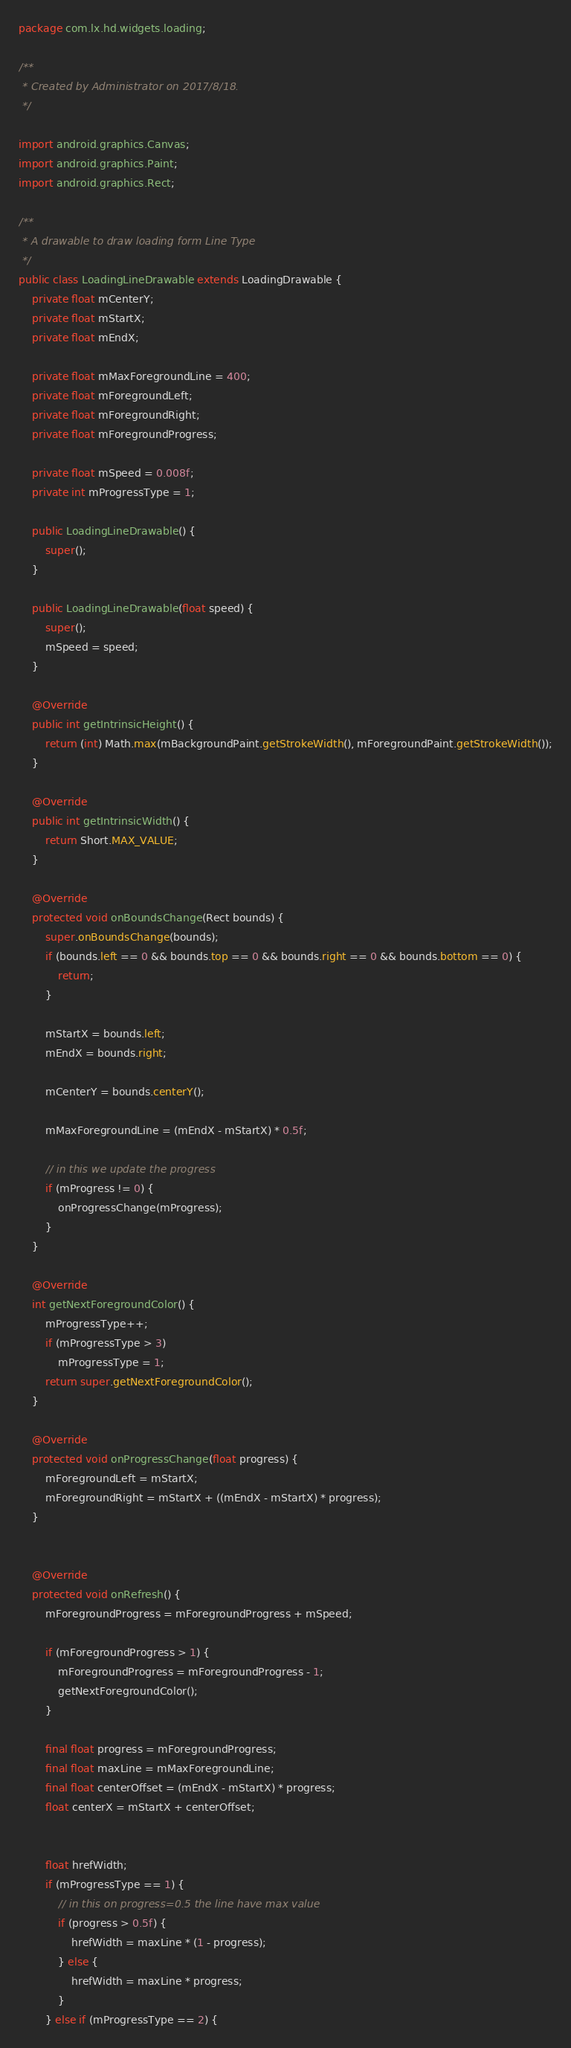<code> <loc_0><loc_0><loc_500><loc_500><_Java_>package com.lx.hd.widgets.loading;

/**
 * Created by Administrator on 2017/8/18.
 */

import android.graphics.Canvas;
import android.graphics.Paint;
import android.graphics.Rect;

/**
 * A drawable to draw loading form Line Type
 */
public class LoadingLineDrawable extends LoadingDrawable {
    private float mCenterY;
    private float mStartX;
    private float mEndX;

    private float mMaxForegroundLine = 400;
    private float mForegroundLeft;
    private float mForegroundRight;
    private float mForegroundProgress;

    private float mSpeed = 0.008f;
    private int mProgressType = 1;

    public LoadingLineDrawable() {
        super();
    }

    public LoadingLineDrawable(float speed) {
        super();
        mSpeed = speed;
    }

    @Override
    public int getIntrinsicHeight() {
        return (int) Math.max(mBackgroundPaint.getStrokeWidth(), mForegroundPaint.getStrokeWidth());
    }

    @Override
    public int getIntrinsicWidth() {
        return Short.MAX_VALUE;
    }

    @Override
    protected void onBoundsChange(Rect bounds) {
        super.onBoundsChange(bounds);
        if (bounds.left == 0 && bounds.top == 0 && bounds.right == 0 && bounds.bottom == 0) {
            return;
        }

        mStartX = bounds.left;
        mEndX = bounds.right;

        mCenterY = bounds.centerY();

        mMaxForegroundLine = (mEndX - mStartX) * 0.5f;

        // in this we update the progress
        if (mProgress != 0) {
            onProgressChange(mProgress);
        }
    }

    @Override
    int getNextForegroundColor() {
        mProgressType++;
        if (mProgressType > 3)
            mProgressType = 1;
        return super.getNextForegroundColor();
    }

    @Override
    protected void onProgressChange(float progress) {
        mForegroundLeft = mStartX;
        mForegroundRight = mStartX + ((mEndX - mStartX) * progress);
    }


    @Override
    protected void onRefresh() {
        mForegroundProgress = mForegroundProgress + mSpeed;

        if (mForegroundProgress > 1) {
            mForegroundProgress = mForegroundProgress - 1;
            getNextForegroundColor();
        }

        final float progress = mForegroundProgress;
        final float maxLine = mMaxForegroundLine;
        final float centerOffset = (mEndX - mStartX) * progress;
        float centerX = mStartX + centerOffset;


        float hrefWidth;
        if (mProgressType == 1) {
            // in this on progress=0.5 the line have max value
            if (progress > 0.5f) {
                hrefWidth = maxLine * (1 - progress);
            } else {
                hrefWidth = maxLine * progress;
            }
        } else if (mProgressType == 2) {</code> 